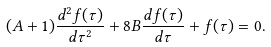Convert formula to latex. <formula><loc_0><loc_0><loc_500><loc_500>( A + 1 ) \frac { d ^ { 2 } f ( \tau ) } { d \tau ^ { 2 } } + 8 B \frac { d f ( \tau ) } { d \tau } + f ( \tau ) = 0 .</formula> 